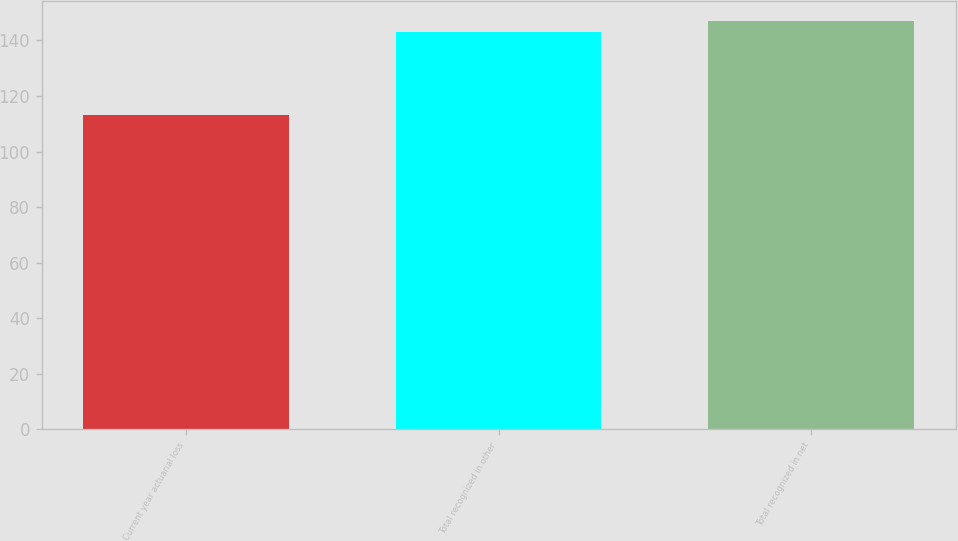<chart> <loc_0><loc_0><loc_500><loc_500><bar_chart><fcel>Current year actuarial loss<fcel>Total recognized in other<fcel>Total recognized in net<nl><fcel>113<fcel>143<fcel>147<nl></chart> 